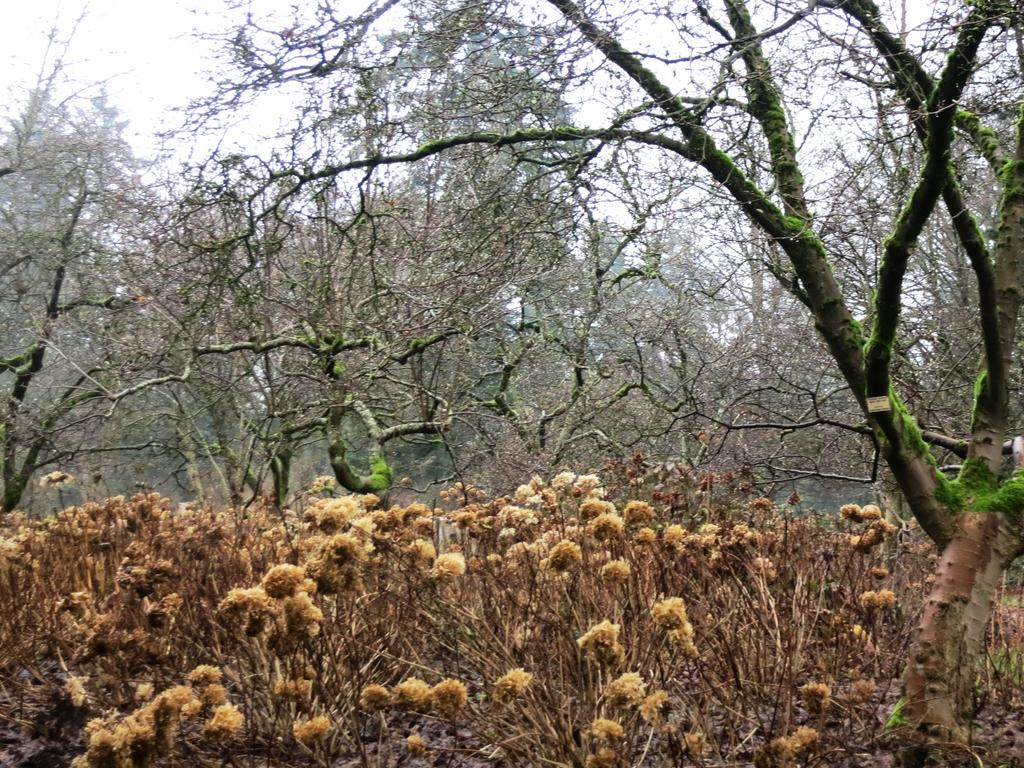What type of vegetation can be seen in the image? There are plants and trees in the image. What is visible in the background of the image? The sky is visible in the background of the image. How would you describe the sky in the image? The sky appears to be clear in the image. What historical event is being commemorated by the men in the image? There are no men present in the image, and therefore no historical event can be observed. What is the name of the downtown area visible in the image? The image does not depict a downtown area, so it cannot be identified. 